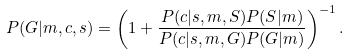<formula> <loc_0><loc_0><loc_500><loc_500>P ( G | m , c , s ) = \left ( 1 + \frac { P ( c | s , m , S ) P ( S | m ) } { P ( c | s , m , G ) P ( G | m ) } \right ) ^ { - 1 } .</formula> 